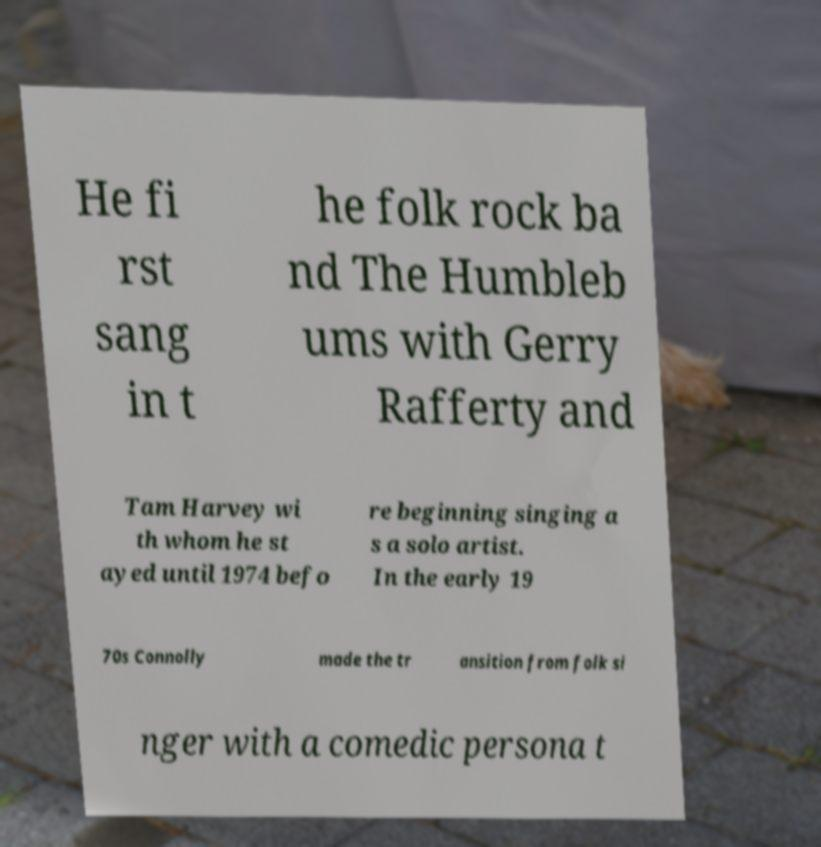For documentation purposes, I need the text within this image transcribed. Could you provide that? He fi rst sang in t he folk rock ba nd The Humbleb ums with Gerry Rafferty and Tam Harvey wi th whom he st ayed until 1974 befo re beginning singing a s a solo artist. In the early 19 70s Connolly made the tr ansition from folk si nger with a comedic persona t 